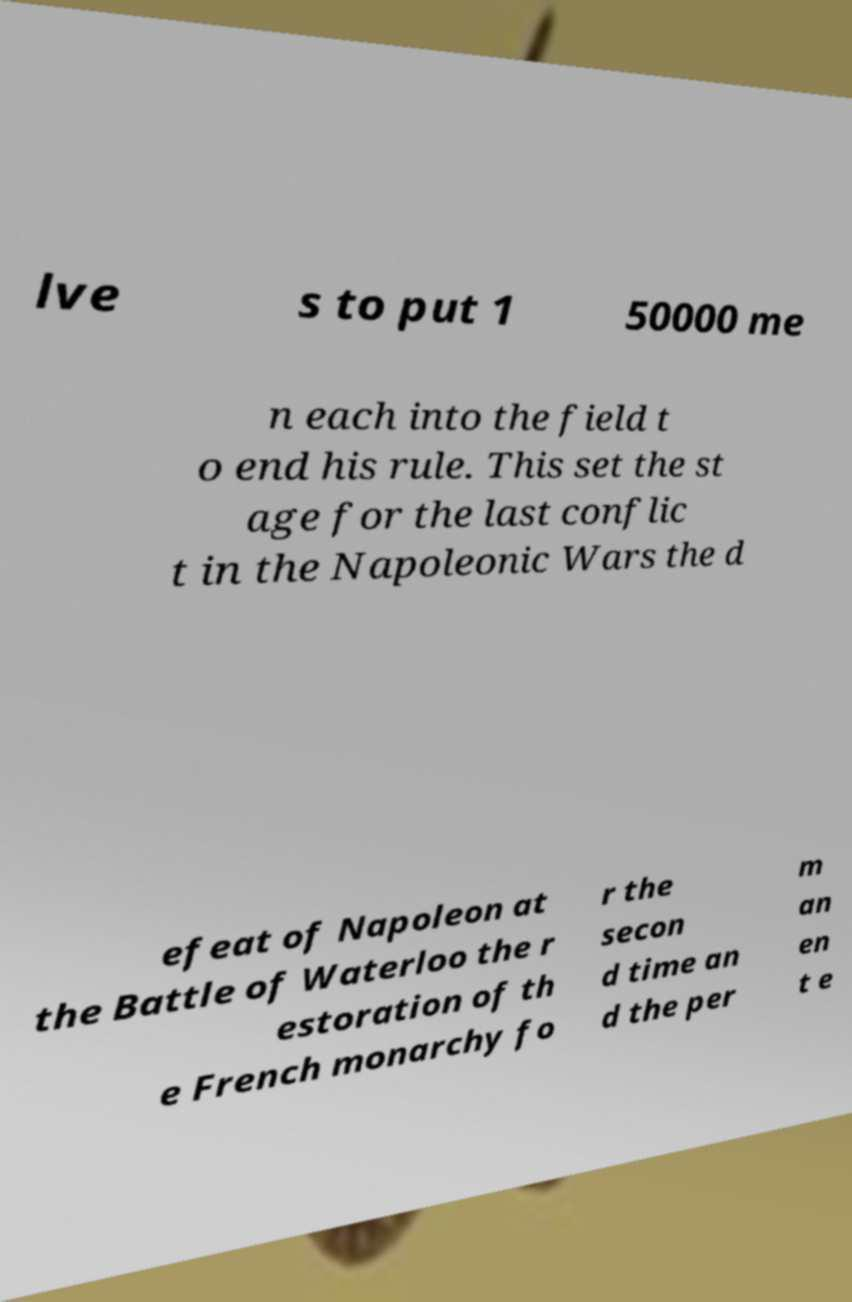Can you accurately transcribe the text from the provided image for me? lve s to put 1 50000 me n each into the field t o end his rule. This set the st age for the last conflic t in the Napoleonic Wars the d efeat of Napoleon at the Battle of Waterloo the r estoration of th e French monarchy fo r the secon d time an d the per m an en t e 